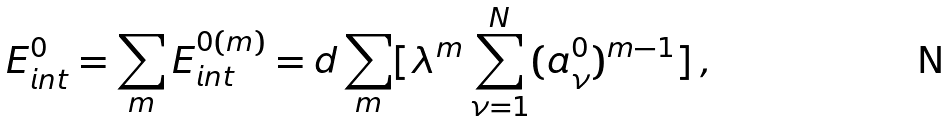Convert formula to latex. <formula><loc_0><loc_0><loc_500><loc_500>E _ { i n t } ^ { 0 } = \sum _ { m } E _ { i n t } ^ { 0 ( m ) } = d \sum _ { m } [ \lambda ^ { m } \sum _ { \nu = 1 } ^ { N } ( a _ { \nu } ^ { 0 } ) ^ { m - 1 } ] \, ,</formula> 